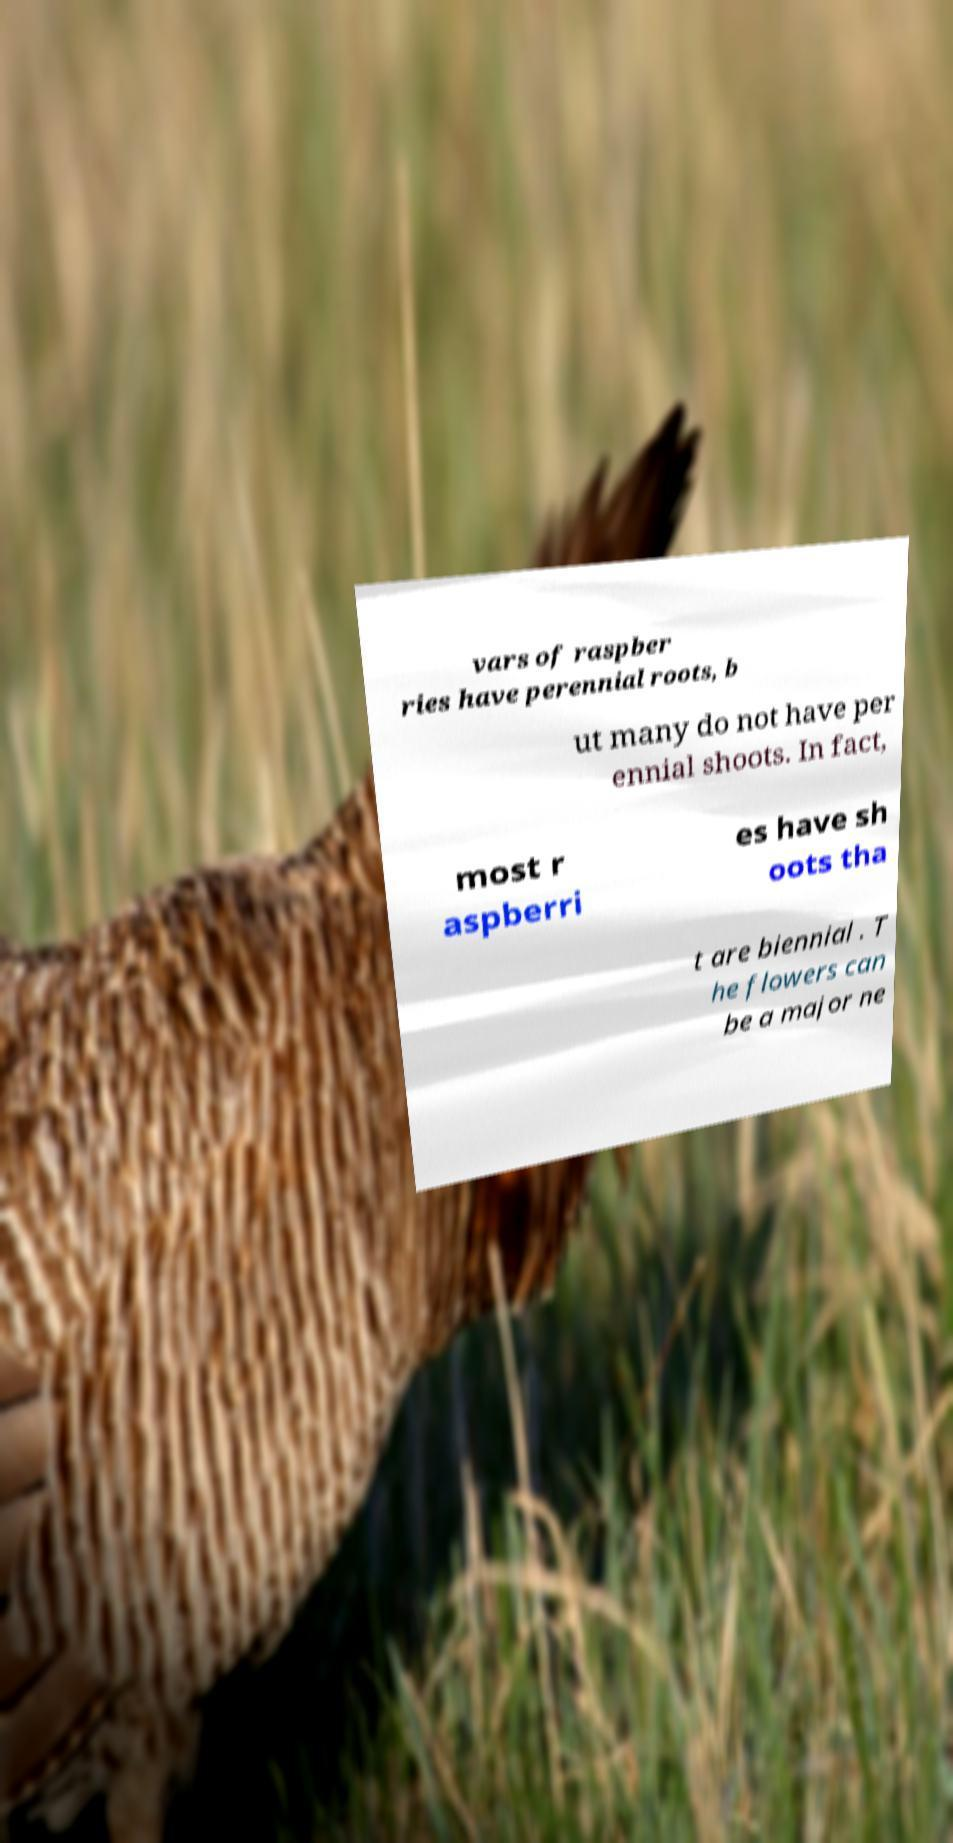I need the written content from this picture converted into text. Can you do that? vars of raspber ries have perennial roots, b ut many do not have per ennial shoots. In fact, most r aspberri es have sh oots tha t are biennial . T he flowers can be a major ne 